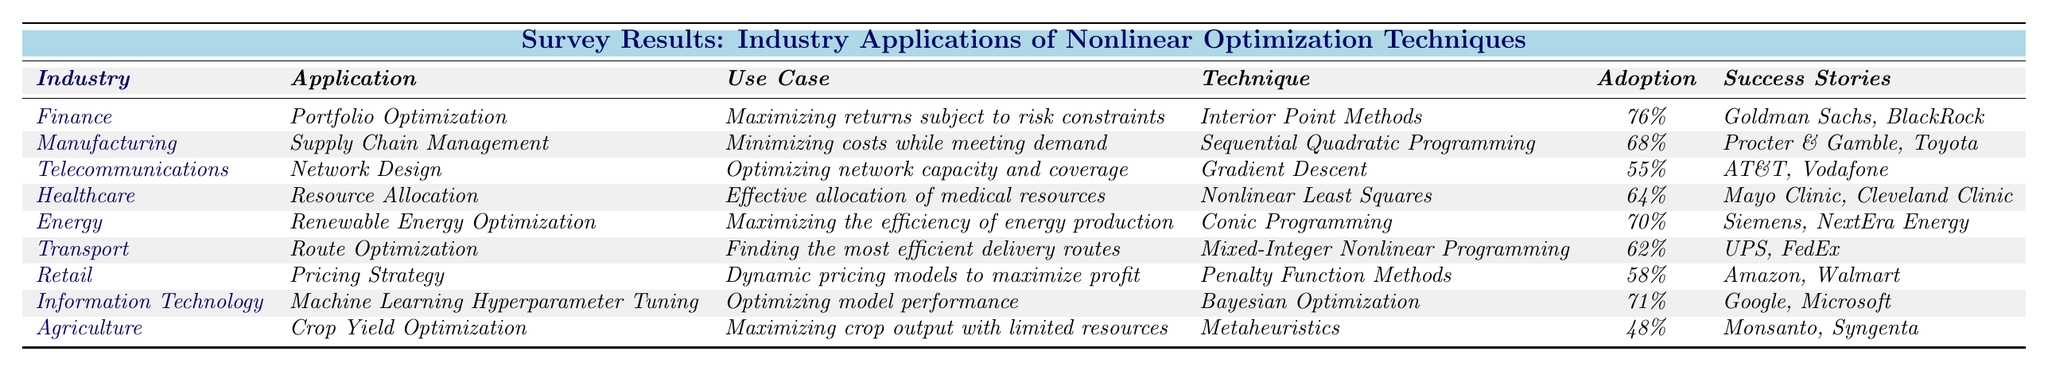What is the adoption rate for Portfolio Optimization in the Finance industry? The table indicates that the adoption rate for Portfolio Optimization is listed under the Finance industry, which is specifically stated as 76%.
Answer: 76% Which industry utilizes Nonlinear Least Squares for resource allocation? The table shows that the Healthcare industry specifically uses Nonlinear Least Squares for effective allocation of medical resources.
Answer: Healthcare What is the average adoption rate for the industries mentioned in the table? The adoption rates listed are: 76%, 68%, 55%, 64%, 70%, 62%, 58%, 71%, and 48%. Summing these gives 76 + 68 + 55 + 64 + 70 + 62 + 58 + 71 + 48 = 622. There are 9 industries, so the average is 622 / 9 = 69.11%.
Answer: 69.11% Is the adoption rate for Network Design in Telecommunications higher than that for Route Optimization in Transport? The adoption rate for Network Design is 55% and for Route Optimization, it is 62%. Since 55% is less than 62%, the statement is false.
Answer: No Which industry has the lowest adoption rate for nonlinear optimization techniques, and what is that rate? By reviewing the adoption rates, Agriculture has the lowest rate at 48%.
Answer: Agriculture, 48% How many success stories are listed for the Healthcare application of Resource Allocation? The Healthcare industry has success stories listed as Mayo Clinic and Cleveland Clinic, which makes a total of 2 success stories.
Answer: 2 Is there any industry with an adoption rate of 50% or below? The table reveals that the Agriculture industry has an adoption rate of 48%, which is less than 50%. Therefore, yes, there is an industry with an adoption rate of 50% or below.
Answer: Yes What technique is associated with Crop Yield Optimization in Agriculture? The technique associated with Crop Yield Optimization is listed as Metaheuristics in the Agriculture industry row.
Answer: Metaheuristics What is the difference between the highest and lowest adoption rates in the table? The highest adoption rate is 76% for Finance, and the lowest is 48% for Agriculture. The difference is 76% - 48% = 28%.
Answer: 28% Which application had a higher adoption rate, Dynamic Pricing Strategy in Retail or Supply Chain Management in Manufacturing? The adoption rate for Pricing Strategy in Retail is 58% and for Supply Chain Management in Manufacturing, it is 68%. Since 68% is greater than 58%, Supply Chain Management has a higher adoption rate.
Answer: Supply Chain Management 